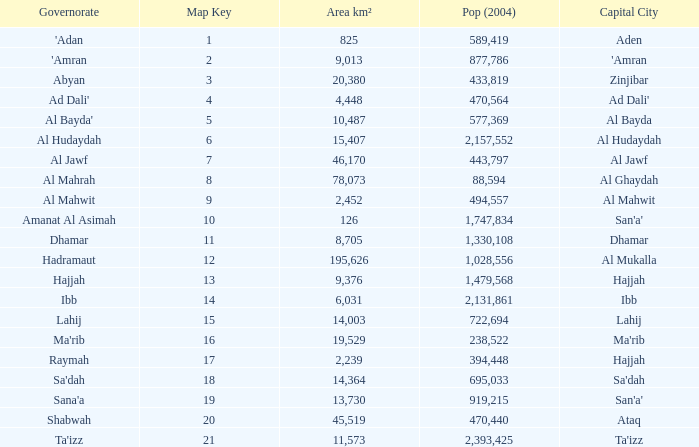Could you parse the entire table as a dict? {'header': ['Governorate', 'Map Key', 'Area km²', 'Pop (2004)', 'Capital City'], 'rows': [["'Adan", '1', '825', '589,419', 'Aden'], ["'Amran", '2', '9,013', '877,786', "'Amran"], ['Abyan', '3', '20,380', '433,819', 'Zinjibar'], ["Ad Dali'", '4', '4,448', '470,564', "Ad Dali'"], ["Al Bayda'", '5', '10,487', '577,369', 'Al Bayda'], ['Al Hudaydah', '6', '15,407', '2,157,552', 'Al Hudaydah'], ['Al Jawf', '7', '46,170', '443,797', 'Al Jawf'], ['Al Mahrah', '8', '78,073', '88,594', 'Al Ghaydah'], ['Al Mahwit', '9', '2,452', '494,557', 'Al Mahwit'], ['Amanat Al Asimah', '10', '126', '1,747,834', "San'a'"], ['Dhamar', '11', '8,705', '1,330,108', 'Dhamar'], ['Hadramaut', '12', '195,626', '1,028,556', 'Al Mukalla'], ['Hajjah', '13', '9,376', '1,479,568', 'Hajjah'], ['Ibb', '14', '6,031', '2,131,861', 'Ibb'], ['Lahij', '15', '14,003', '722,694', 'Lahij'], ["Ma'rib", '16', '19,529', '238,522', "Ma'rib"], ['Raymah', '17', '2,239', '394,448', 'Hajjah'], ["Sa'dah", '18', '14,364', '695,033', "Sa'dah"], ["Sana'a", '19', '13,730', '919,215', "San'a'"], ['Shabwah', '20', '45,519', '470,440', 'Ataq'], ["Ta'izz", '21', '11,573', '2,393,425', "Ta'izz"]]} How many Map Key has an Area km² larger than 14,003 and a Capital City of al mukalla, and a Pop (2004) larger than 1,028,556? None. 